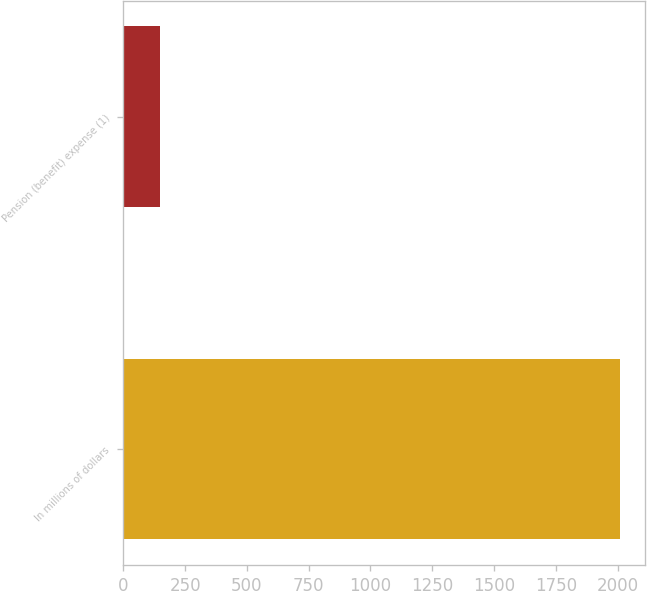Convert chart. <chart><loc_0><loc_0><loc_500><loc_500><bar_chart><fcel>In millions of dollars<fcel>Pension (benefit) expense (1)<nl><fcel>2009<fcel>148<nl></chart> 